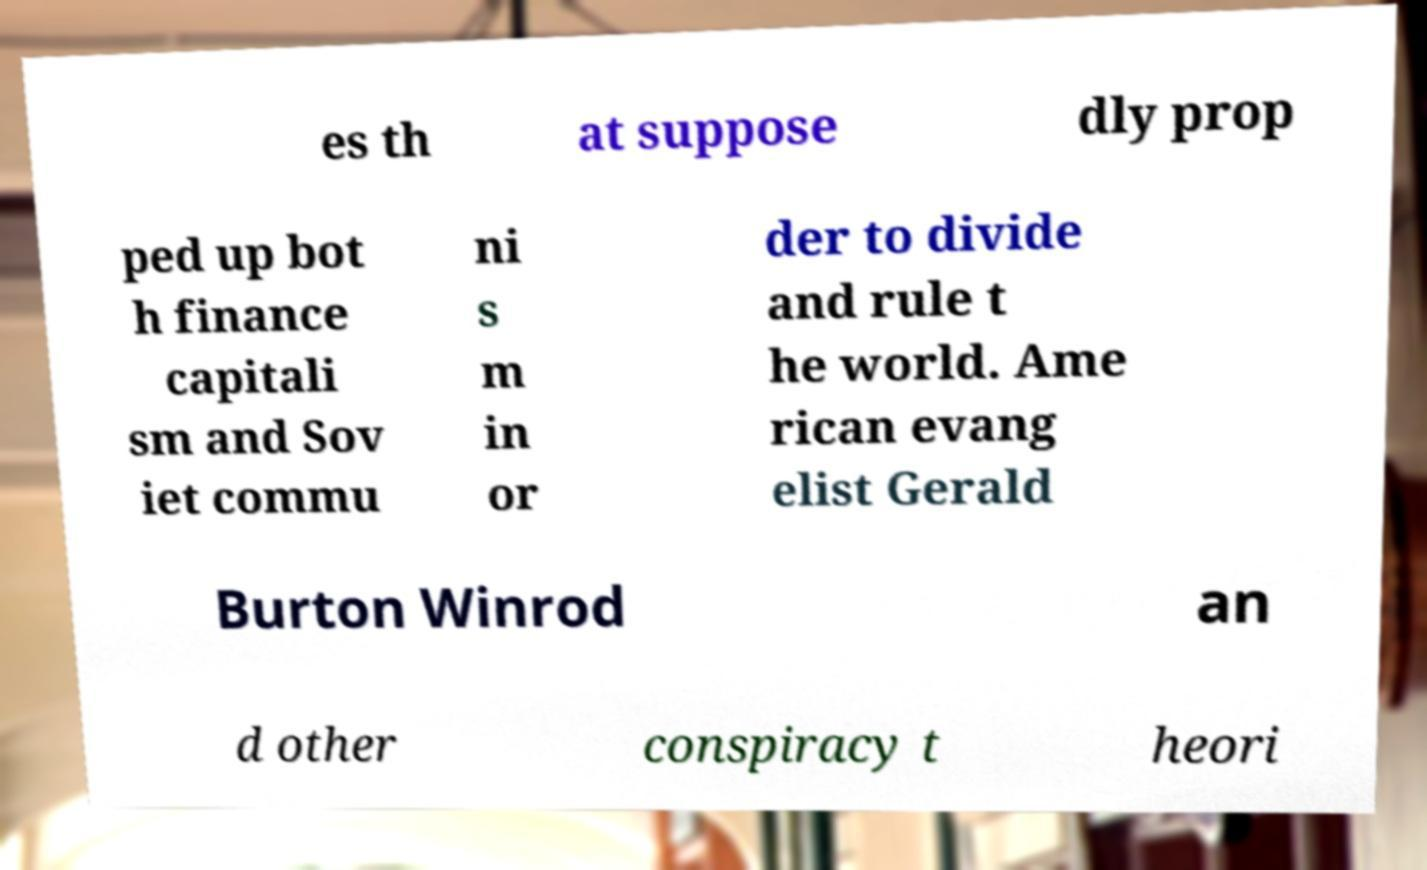Could you assist in decoding the text presented in this image and type it out clearly? es th at suppose dly prop ped up bot h finance capitali sm and Sov iet commu ni s m in or der to divide and rule t he world. Ame rican evang elist Gerald Burton Winrod an d other conspiracy t heori 